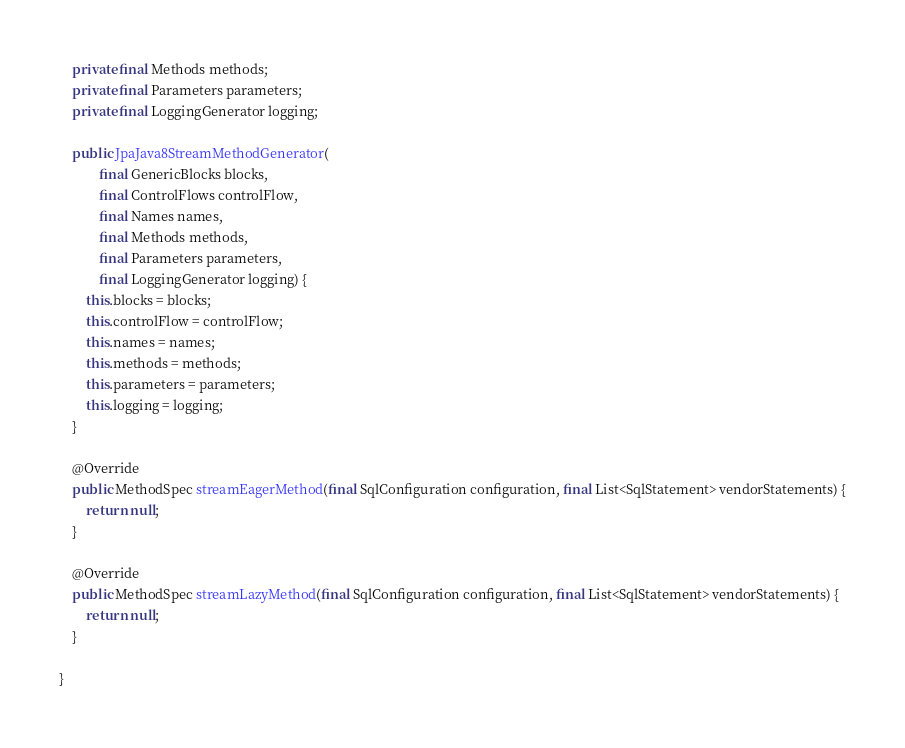<code> <loc_0><loc_0><loc_500><loc_500><_Java_>    private final Methods methods;
    private final Parameters parameters;
    private final LoggingGenerator logging;

    public JpaJava8StreamMethodGenerator(
            final GenericBlocks blocks,
            final ControlFlows controlFlow,
            final Names names,
            final Methods methods,
            final Parameters parameters,
            final LoggingGenerator logging) {
        this.blocks = blocks;
        this.controlFlow = controlFlow;
        this.names = names;
        this.methods = methods;
        this.parameters = parameters;
        this.logging = logging;
    }

    @Override
    public MethodSpec streamEagerMethod(final SqlConfiguration configuration, final List<SqlStatement> vendorStatements) {
        return null;
    }

    @Override
    public MethodSpec streamLazyMethod(final SqlConfiguration configuration, final List<SqlStatement> vendorStatements) {
        return null;
    }

}
</code> 